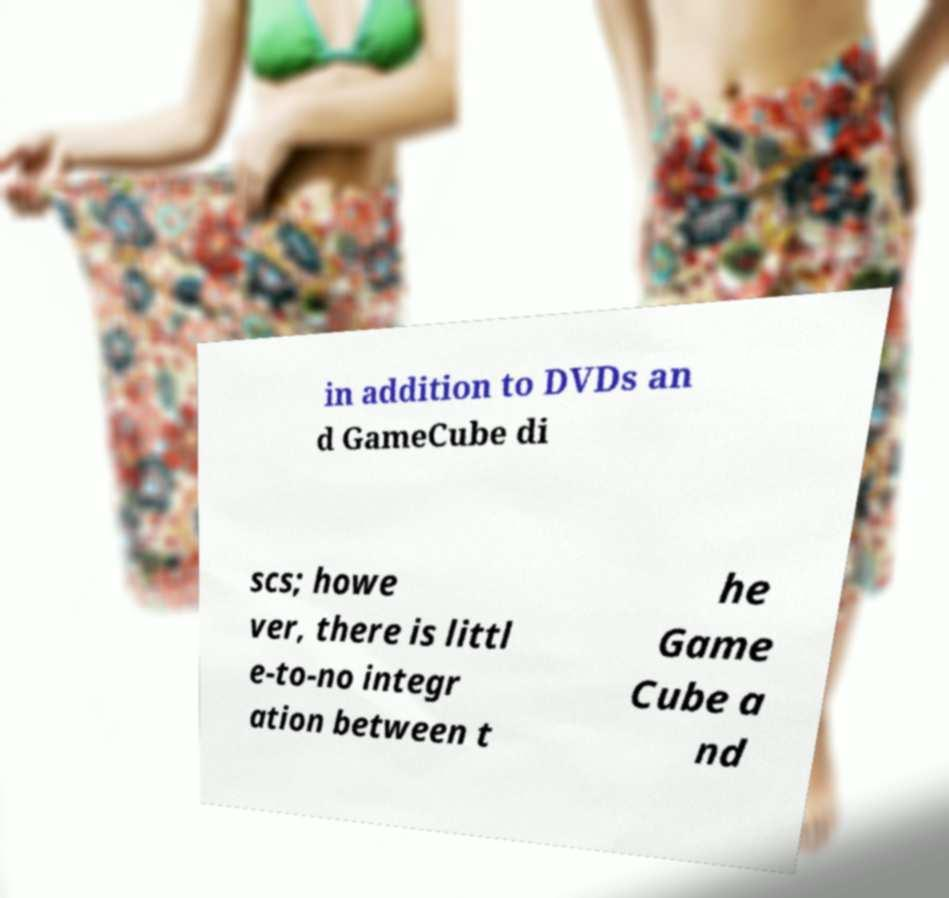There's text embedded in this image that I need extracted. Can you transcribe it verbatim? in addition to DVDs an d GameCube di scs; howe ver, there is littl e-to-no integr ation between t he Game Cube a nd 